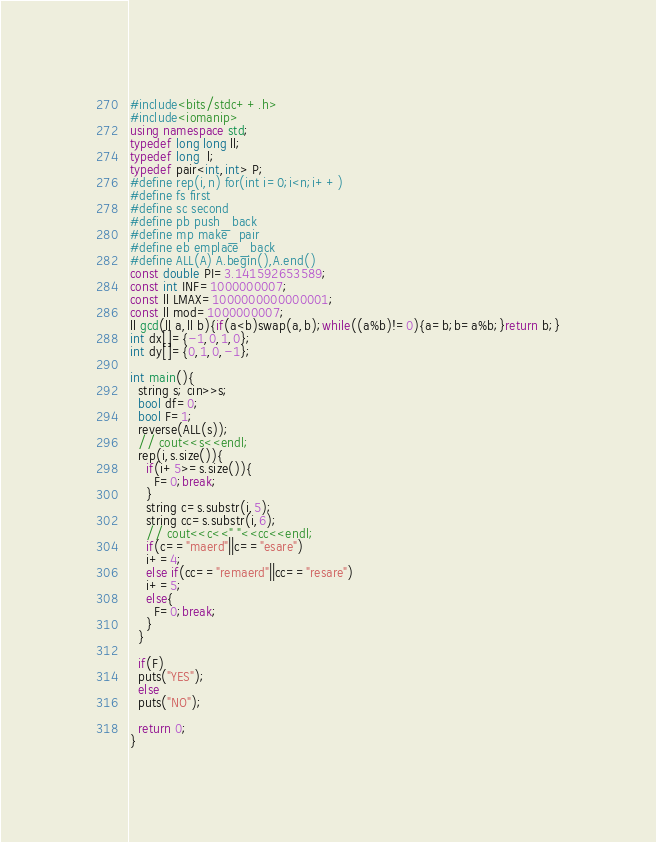Convert code to text. <code><loc_0><loc_0><loc_500><loc_500><_C++_>#include<bits/stdc++.h>
#include<iomanip>
using namespace std;
typedef long long ll;
typedef long  l;
typedef pair<int,int> P;
#define rep(i,n) for(int i=0;i<n;i++)
#define fs first
#define sc second
#define pb push_back
#define mp make_pair
#define eb emplace_back
#define ALL(A) A.begin(),A.end()
const double PI=3.141592653589;
const int INF=1000000007;
const ll LMAX=1000000000000001;
const ll mod=1000000007;
ll gcd(ll a,ll b){if(a<b)swap(a,b);while((a%b)!=0){a=b;b=a%b;}return b;}
int dx[]={-1,0,1,0};
int dy[]={0,1,0,-1};

int main(){
  string s; cin>>s;
  bool df=0;
  bool F=1;
  reverse(ALL(s));
  // cout<<s<<endl;
  rep(i,s.size()){
    if(i+5>=s.size()){
      F=0;break;
    }
    string c=s.substr(i,5);
    string cc=s.substr(i,6);
    // cout<<c<<" "<<cc<<endl;
    if(c=="maerd"||c=="esare")
    i+=4;
    else if(cc=="remaerd"||cc=="resare")
    i+=5;
    else{
      F=0;break;
    }
  }

  if(F)
  puts("YES");
  else
  puts("NO");

  return 0;
}
</code> 